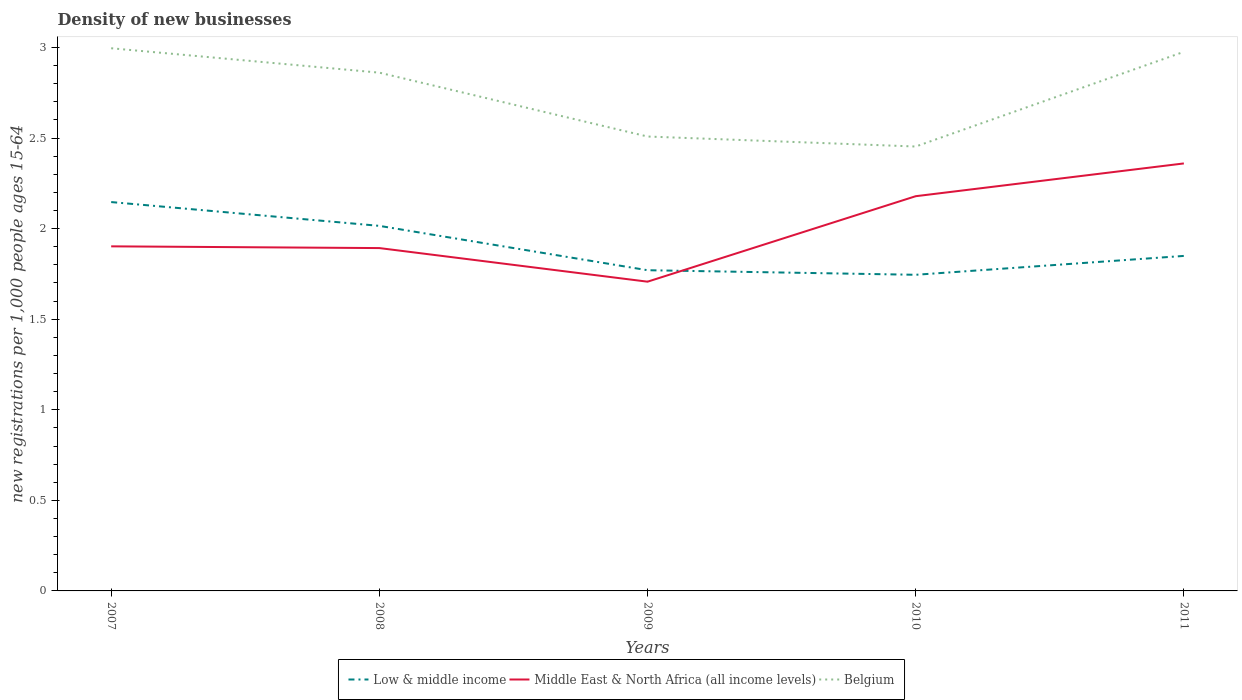How many different coloured lines are there?
Your answer should be compact. 3. Is the number of lines equal to the number of legend labels?
Your answer should be very brief. Yes. Across all years, what is the maximum number of new registrations in Belgium?
Ensure brevity in your answer.  2.45. In which year was the number of new registrations in Low & middle income maximum?
Give a very brief answer. 2010. What is the total number of new registrations in Belgium in the graph?
Your answer should be very brief. 0.13. What is the difference between the highest and the second highest number of new registrations in Middle East & North Africa (all income levels)?
Your answer should be very brief. 0.65. Is the number of new registrations in Middle East & North Africa (all income levels) strictly greater than the number of new registrations in Low & middle income over the years?
Offer a very short reply. No. How many lines are there?
Your answer should be very brief. 3. Does the graph contain any zero values?
Give a very brief answer. No. Where does the legend appear in the graph?
Provide a short and direct response. Bottom center. What is the title of the graph?
Make the answer very short. Density of new businesses. Does "Singapore" appear as one of the legend labels in the graph?
Provide a succinct answer. No. What is the label or title of the Y-axis?
Provide a short and direct response. New registrations per 1,0 people ages 15-64. What is the new registrations per 1,000 people ages 15-64 of Low & middle income in 2007?
Your answer should be very brief. 2.15. What is the new registrations per 1,000 people ages 15-64 of Middle East & North Africa (all income levels) in 2007?
Offer a very short reply. 1.9. What is the new registrations per 1,000 people ages 15-64 in Belgium in 2007?
Ensure brevity in your answer.  3. What is the new registrations per 1,000 people ages 15-64 in Low & middle income in 2008?
Your response must be concise. 2.02. What is the new registrations per 1,000 people ages 15-64 in Middle East & North Africa (all income levels) in 2008?
Keep it short and to the point. 1.89. What is the new registrations per 1,000 people ages 15-64 of Belgium in 2008?
Your answer should be very brief. 2.86. What is the new registrations per 1,000 people ages 15-64 of Low & middle income in 2009?
Provide a short and direct response. 1.77. What is the new registrations per 1,000 people ages 15-64 of Middle East & North Africa (all income levels) in 2009?
Ensure brevity in your answer.  1.71. What is the new registrations per 1,000 people ages 15-64 in Belgium in 2009?
Your answer should be compact. 2.51. What is the new registrations per 1,000 people ages 15-64 of Low & middle income in 2010?
Provide a short and direct response. 1.75. What is the new registrations per 1,000 people ages 15-64 of Middle East & North Africa (all income levels) in 2010?
Make the answer very short. 2.18. What is the new registrations per 1,000 people ages 15-64 of Belgium in 2010?
Keep it short and to the point. 2.45. What is the new registrations per 1,000 people ages 15-64 in Low & middle income in 2011?
Give a very brief answer. 1.85. What is the new registrations per 1,000 people ages 15-64 in Middle East & North Africa (all income levels) in 2011?
Your response must be concise. 2.36. What is the new registrations per 1,000 people ages 15-64 in Belgium in 2011?
Your response must be concise. 2.98. Across all years, what is the maximum new registrations per 1,000 people ages 15-64 in Low & middle income?
Give a very brief answer. 2.15. Across all years, what is the maximum new registrations per 1,000 people ages 15-64 in Middle East & North Africa (all income levels)?
Offer a very short reply. 2.36. Across all years, what is the maximum new registrations per 1,000 people ages 15-64 of Belgium?
Your answer should be compact. 3. Across all years, what is the minimum new registrations per 1,000 people ages 15-64 of Low & middle income?
Provide a succinct answer. 1.75. Across all years, what is the minimum new registrations per 1,000 people ages 15-64 in Middle East & North Africa (all income levels)?
Your answer should be very brief. 1.71. Across all years, what is the minimum new registrations per 1,000 people ages 15-64 in Belgium?
Make the answer very short. 2.45. What is the total new registrations per 1,000 people ages 15-64 in Low & middle income in the graph?
Ensure brevity in your answer.  9.53. What is the total new registrations per 1,000 people ages 15-64 of Middle East & North Africa (all income levels) in the graph?
Provide a succinct answer. 10.04. What is the total new registrations per 1,000 people ages 15-64 in Belgium in the graph?
Offer a very short reply. 13.8. What is the difference between the new registrations per 1,000 people ages 15-64 of Low & middle income in 2007 and that in 2008?
Give a very brief answer. 0.13. What is the difference between the new registrations per 1,000 people ages 15-64 of Middle East & North Africa (all income levels) in 2007 and that in 2008?
Provide a succinct answer. 0.01. What is the difference between the new registrations per 1,000 people ages 15-64 of Belgium in 2007 and that in 2008?
Give a very brief answer. 0.13. What is the difference between the new registrations per 1,000 people ages 15-64 of Low & middle income in 2007 and that in 2009?
Your answer should be very brief. 0.38. What is the difference between the new registrations per 1,000 people ages 15-64 in Middle East & North Africa (all income levels) in 2007 and that in 2009?
Your response must be concise. 0.2. What is the difference between the new registrations per 1,000 people ages 15-64 in Belgium in 2007 and that in 2009?
Offer a terse response. 0.49. What is the difference between the new registrations per 1,000 people ages 15-64 in Low & middle income in 2007 and that in 2010?
Your answer should be compact. 0.4. What is the difference between the new registrations per 1,000 people ages 15-64 of Middle East & North Africa (all income levels) in 2007 and that in 2010?
Your answer should be very brief. -0.28. What is the difference between the new registrations per 1,000 people ages 15-64 of Belgium in 2007 and that in 2010?
Keep it short and to the point. 0.54. What is the difference between the new registrations per 1,000 people ages 15-64 in Low & middle income in 2007 and that in 2011?
Offer a terse response. 0.3. What is the difference between the new registrations per 1,000 people ages 15-64 in Middle East & North Africa (all income levels) in 2007 and that in 2011?
Ensure brevity in your answer.  -0.46. What is the difference between the new registrations per 1,000 people ages 15-64 of Belgium in 2007 and that in 2011?
Ensure brevity in your answer.  0.02. What is the difference between the new registrations per 1,000 people ages 15-64 in Low & middle income in 2008 and that in 2009?
Offer a very short reply. 0.24. What is the difference between the new registrations per 1,000 people ages 15-64 of Middle East & North Africa (all income levels) in 2008 and that in 2009?
Offer a terse response. 0.19. What is the difference between the new registrations per 1,000 people ages 15-64 of Belgium in 2008 and that in 2009?
Your answer should be compact. 0.35. What is the difference between the new registrations per 1,000 people ages 15-64 of Low & middle income in 2008 and that in 2010?
Provide a short and direct response. 0.27. What is the difference between the new registrations per 1,000 people ages 15-64 of Middle East & North Africa (all income levels) in 2008 and that in 2010?
Keep it short and to the point. -0.29. What is the difference between the new registrations per 1,000 people ages 15-64 of Belgium in 2008 and that in 2010?
Offer a terse response. 0.41. What is the difference between the new registrations per 1,000 people ages 15-64 of Low & middle income in 2008 and that in 2011?
Keep it short and to the point. 0.17. What is the difference between the new registrations per 1,000 people ages 15-64 of Middle East & North Africa (all income levels) in 2008 and that in 2011?
Ensure brevity in your answer.  -0.47. What is the difference between the new registrations per 1,000 people ages 15-64 of Belgium in 2008 and that in 2011?
Your answer should be compact. -0.12. What is the difference between the new registrations per 1,000 people ages 15-64 of Low & middle income in 2009 and that in 2010?
Your response must be concise. 0.03. What is the difference between the new registrations per 1,000 people ages 15-64 in Middle East & North Africa (all income levels) in 2009 and that in 2010?
Your response must be concise. -0.47. What is the difference between the new registrations per 1,000 people ages 15-64 of Belgium in 2009 and that in 2010?
Offer a very short reply. 0.06. What is the difference between the new registrations per 1,000 people ages 15-64 of Low & middle income in 2009 and that in 2011?
Provide a succinct answer. -0.08. What is the difference between the new registrations per 1,000 people ages 15-64 of Middle East & North Africa (all income levels) in 2009 and that in 2011?
Your response must be concise. -0.65. What is the difference between the new registrations per 1,000 people ages 15-64 of Belgium in 2009 and that in 2011?
Ensure brevity in your answer.  -0.47. What is the difference between the new registrations per 1,000 people ages 15-64 of Low & middle income in 2010 and that in 2011?
Offer a very short reply. -0.1. What is the difference between the new registrations per 1,000 people ages 15-64 of Middle East & North Africa (all income levels) in 2010 and that in 2011?
Offer a very short reply. -0.18. What is the difference between the new registrations per 1,000 people ages 15-64 in Belgium in 2010 and that in 2011?
Give a very brief answer. -0.52. What is the difference between the new registrations per 1,000 people ages 15-64 in Low & middle income in 2007 and the new registrations per 1,000 people ages 15-64 in Middle East & North Africa (all income levels) in 2008?
Provide a succinct answer. 0.25. What is the difference between the new registrations per 1,000 people ages 15-64 in Low & middle income in 2007 and the new registrations per 1,000 people ages 15-64 in Belgium in 2008?
Your response must be concise. -0.71. What is the difference between the new registrations per 1,000 people ages 15-64 of Middle East & North Africa (all income levels) in 2007 and the new registrations per 1,000 people ages 15-64 of Belgium in 2008?
Your answer should be very brief. -0.96. What is the difference between the new registrations per 1,000 people ages 15-64 in Low & middle income in 2007 and the new registrations per 1,000 people ages 15-64 in Middle East & North Africa (all income levels) in 2009?
Your answer should be very brief. 0.44. What is the difference between the new registrations per 1,000 people ages 15-64 in Low & middle income in 2007 and the new registrations per 1,000 people ages 15-64 in Belgium in 2009?
Your response must be concise. -0.36. What is the difference between the new registrations per 1,000 people ages 15-64 of Middle East & North Africa (all income levels) in 2007 and the new registrations per 1,000 people ages 15-64 of Belgium in 2009?
Make the answer very short. -0.61. What is the difference between the new registrations per 1,000 people ages 15-64 of Low & middle income in 2007 and the new registrations per 1,000 people ages 15-64 of Middle East & North Africa (all income levels) in 2010?
Your answer should be compact. -0.03. What is the difference between the new registrations per 1,000 people ages 15-64 of Low & middle income in 2007 and the new registrations per 1,000 people ages 15-64 of Belgium in 2010?
Keep it short and to the point. -0.31. What is the difference between the new registrations per 1,000 people ages 15-64 in Middle East & North Africa (all income levels) in 2007 and the new registrations per 1,000 people ages 15-64 in Belgium in 2010?
Your answer should be compact. -0.55. What is the difference between the new registrations per 1,000 people ages 15-64 of Low & middle income in 2007 and the new registrations per 1,000 people ages 15-64 of Middle East & North Africa (all income levels) in 2011?
Provide a short and direct response. -0.21. What is the difference between the new registrations per 1,000 people ages 15-64 of Low & middle income in 2007 and the new registrations per 1,000 people ages 15-64 of Belgium in 2011?
Ensure brevity in your answer.  -0.83. What is the difference between the new registrations per 1,000 people ages 15-64 of Middle East & North Africa (all income levels) in 2007 and the new registrations per 1,000 people ages 15-64 of Belgium in 2011?
Your answer should be very brief. -1.07. What is the difference between the new registrations per 1,000 people ages 15-64 of Low & middle income in 2008 and the new registrations per 1,000 people ages 15-64 of Middle East & North Africa (all income levels) in 2009?
Your answer should be very brief. 0.31. What is the difference between the new registrations per 1,000 people ages 15-64 in Low & middle income in 2008 and the new registrations per 1,000 people ages 15-64 in Belgium in 2009?
Offer a terse response. -0.49. What is the difference between the new registrations per 1,000 people ages 15-64 in Middle East & North Africa (all income levels) in 2008 and the new registrations per 1,000 people ages 15-64 in Belgium in 2009?
Your answer should be compact. -0.62. What is the difference between the new registrations per 1,000 people ages 15-64 in Low & middle income in 2008 and the new registrations per 1,000 people ages 15-64 in Middle East & North Africa (all income levels) in 2010?
Ensure brevity in your answer.  -0.16. What is the difference between the new registrations per 1,000 people ages 15-64 of Low & middle income in 2008 and the new registrations per 1,000 people ages 15-64 of Belgium in 2010?
Ensure brevity in your answer.  -0.44. What is the difference between the new registrations per 1,000 people ages 15-64 in Middle East & North Africa (all income levels) in 2008 and the new registrations per 1,000 people ages 15-64 in Belgium in 2010?
Provide a succinct answer. -0.56. What is the difference between the new registrations per 1,000 people ages 15-64 in Low & middle income in 2008 and the new registrations per 1,000 people ages 15-64 in Middle East & North Africa (all income levels) in 2011?
Offer a very short reply. -0.34. What is the difference between the new registrations per 1,000 people ages 15-64 in Low & middle income in 2008 and the new registrations per 1,000 people ages 15-64 in Belgium in 2011?
Offer a terse response. -0.96. What is the difference between the new registrations per 1,000 people ages 15-64 of Middle East & North Africa (all income levels) in 2008 and the new registrations per 1,000 people ages 15-64 of Belgium in 2011?
Offer a very short reply. -1.08. What is the difference between the new registrations per 1,000 people ages 15-64 in Low & middle income in 2009 and the new registrations per 1,000 people ages 15-64 in Middle East & North Africa (all income levels) in 2010?
Ensure brevity in your answer.  -0.41. What is the difference between the new registrations per 1,000 people ages 15-64 in Low & middle income in 2009 and the new registrations per 1,000 people ages 15-64 in Belgium in 2010?
Offer a terse response. -0.68. What is the difference between the new registrations per 1,000 people ages 15-64 in Middle East & North Africa (all income levels) in 2009 and the new registrations per 1,000 people ages 15-64 in Belgium in 2010?
Your answer should be very brief. -0.75. What is the difference between the new registrations per 1,000 people ages 15-64 in Low & middle income in 2009 and the new registrations per 1,000 people ages 15-64 in Middle East & North Africa (all income levels) in 2011?
Your response must be concise. -0.59. What is the difference between the new registrations per 1,000 people ages 15-64 of Low & middle income in 2009 and the new registrations per 1,000 people ages 15-64 of Belgium in 2011?
Your answer should be very brief. -1.21. What is the difference between the new registrations per 1,000 people ages 15-64 of Middle East & North Africa (all income levels) in 2009 and the new registrations per 1,000 people ages 15-64 of Belgium in 2011?
Provide a short and direct response. -1.27. What is the difference between the new registrations per 1,000 people ages 15-64 of Low & middle income in 2010 and the new registrations per 1,000 people ages 15-64 of Middle East & North Africa (all income levels) in 2011?
Give a very brief answer. -0.61. What is the difference between the new registrations per 1,000 people ages 15-64 of Low & middle income in 2010 and the new registrations per 1,000 people ages 15-64 of Belgium in 2011?
Ensure brevity in your answer.  -1.23. What is the difference between the new registrations per 1,000 people ages 15-64 in Middle East & North Africa (all income levels) in 2010 and the new registrations per 1,000 people ages 15-64 in Belgium in 2011?
Ensure brevity in your answer.  -0.8. What is the average new registrations per 1,000 people ages 15-64 of Low & middle income per year?
Make the answer very short. 1.91. What is the average new registrations per 1,000 people ages 15-64 of Middle East & North Africa (all income levels) per year?
Keep it short and to the point. 2.01. What is the average new registrations per 1,000 people ages 15-64 of Belgium per year?
Your answer should be very brief. 2.76. In the year 2007, what is the difference between the new registrations per 1,000 people ages 15-64 of Low & middle income and new registrations per 1,000 people ages 15-64 of Middle East & North Africa (all income levels)?
Offer a very short reply. 0.24. In the year 2007, what is the difference between the new registrations per 1,000 people ages 15-64 of Low & middle income and new registrations per 1,000 people ages 15-64 of Belgium?
Provide a short and direct response. -0.85. In the year 2007, what is the difference between the new registrations per 1,000 people ages 15-64 of Middle East & North Africa (all income levels) and new registrations per 1,000 people ages 15-64 of Belgium?
Provide a short and direct response. -1.09. In the year 2008, what is the difference between the new registrations per 1,000 people ages 15-64 in Low & middle income and new registrations per 1,000 people ages 15-64 in Middle East & North Africa (all income levels)?
Offer a terse response. 0.12. In the year 2008, what is the difference between the new registrations per 1,000 people ages 15-64 in Low & middle income and new registrations per 1,000 people ages 15-64 in Belgium?
Make the answer very short. -0.85. In the year 2008, what is the difference between the new registrations per 1,000 people ages 15-64 of Middle East & North Africa (all income levels) and new registrations per 1,000 people ages 15-64 of Belgium?
Provide a short and direct response. -0.97. In the year 2009, what is the difference between the new registrations per 1,000 people ages 15-64 in Low & middle income and new registrations per 1,000 people ages 15-64 in Middle East & North Africa (all income levels)?
Offer a terse response. 0.06. In the year 2009, what is the difference between the new registrations per 1,000 people ages 15-64 in Low & middle income and new registrations per 1,000 people ages 15-64 in Belgium?
Make the answer very short. -0.74. In the year 2009, what is the difference between the new registrations per 1,000 people ages 15-64 of Middle East & North Africa (all income levels) and new registrations per 1,000 people ages 15-64 of Belgium?
Your answer should be compact. -0.8. In the year 2010, what is the difference between the new registrations per 1,000 people ages 15-64 in Low & middle income and new registrations per 1,000 people ages 15-64 in Middle East & North Africa (all income levels)?
Your answer should be compact. -0.43. In the year 2010, what is the difference between the new registrations per 1,000 people ages 15-64 in Low & middle income and new registrations per 1,000 people ages 15-64 in Belgium?
Your answer should be very brief. -0.71. In the year 2010, what is the difference between the new registrations per 1,000 people ages 15-64 in Middle East & North Africa (all income levels) and new registrations per 1,000 people ages 15-64 in Belgium?
Your answer should be compact. -0.27. In the year 2011, what is the difference between the new registrations per 1,000 people ages 15-64 in Low & middle income and new registrations per 1,000 people ages 15-64 in Middle East & North Africa (all income levels)?
Offer a very short reply. -0.51. In the year 2011, what is the difference between the new registrations per 1,000 people ages 15-64 of Low & middle income and new registrations per 1,000 people ages 15-64 of Belgium?
Offer a very short reply. -1.13. In the year 2011, what is the difference between the new registrations per 1,000 people ages 15-64 in Middle East & North Africa (all income levels) and new registrations per 1,000 people ages 15-64 in Belgium?
Your answer should be very brief. -0.62. What is the ratio of the new registrations per 1,000 people ages 15-64 of Low & middle income in 2007 to that in 2008?
Ensure brevity in your answer.  1.07. What is the ratio of the new registrations per 1,000 people ages 15-64 in Belgium in 2007 to that in 2008?
Offer a terse response. 1.05. What is the ratio of the new registrations per 1,000 people ages 15-64 in Low & middle income in 2007 to that in 2009?
Offer a very short reply. 1.21. What is the ratio of the new registrations per 1,000 people ages 15-64 of Middle East & North Africa (all income levels) in 2007 to that in 2009?
Give a very brief answer. 1.11. What is the ratio of the new registrations per 1,000 people ages 15-64 of Belgium in 2007 to that in 2009?
Your response must be concise. 1.19. What is the ratio of the new registrations per 1,000 people ages 15-64 in Low & middle income in 2007 to that in 2010?
Your answer should be very brief. 1.23. What is the ratio of the new registrations per 1,000 people ages 15-64 in Middle East & North Africa (all income levels) in 2007 to that in 2010?
Make the answer very short. 0.87. What is the ratio of the new registrations per 1,000 people ages 15-64 in Belgium in 2007 to that in 2010?
Make the answer very short. 1.22. What is the ratio of the new registrations per 1,000 people ages 15-64 in Low & middle income in 2007 to that in 2011?
Offer a very short reply. 1.16. What is the ratio of the new registrations per 1,000 people ages 15-64 of Middle East & North Africa (all income levels) in 2007 to that in 2011?
Offer a terse response. 0.81. What is the ratio of the new registrations per 1,000 people ages 15-64 of Low & middle income in 2008 to that in 2009?
Keep it short and to the point. 1.14. What is the ratio of the new registrations per 1,000 people ages 15-64 in Middle East & North Africa (all income levels) in 2008 to that in 2009?
Give a very brief answer. 1.11. What is the ratio of the new registrations per 1,000 people ages 15-64 of Belgium in 2008 to that in 2009?
Keep it short and to the point. 1.14. What is the ratio of the new registrations per 1,000 people ages 15-64 in Low & middle income in 2008 to that in 2010?
Offer a terse response. 1.15. What is the ratio of the new registrations per 1,000 people ages 15-64 of Middle East & North Africa (all income levels) in 2008 to that in 2010?
Your answer should be very brief. 0.87. What is the ratio of the new registrations per 1,000 people ages 15-64 in Belgium in 2008 to that in 2010?
Provide a succinct answer. 1.17. What is the ratio of the new registrations per 1,000 people ages 15-64 of Low & middle income in 2008 to that in 2011?
Your answer should be very brief. 1.09. What is the ratio of the new registrations per 1,000 people ages 15-64 of Middle East & North Africa (all income levels) in 2008 to that in 2011?
Your answer should be compact. 0.8. What is the ratio of the new registrations per 1,000 people ages 15-64 of Belgium in 2008 to that in 2011?
Your answer should be compact. 0.96. What is the ratio of the new registrations per 1,000 people ages 15-64 in Low & middle income in 2009 to that in 2010?
Offer a terse response. 1.01. What is the ratio of the new registrations per 1,000 people ages 15-64 of Middle East & North Africa (all income levels) in 2009 to that in 2010?
Your answer should be compact. 0.78. What is the ratio of the new registrations per 1,000 people ages 15-64 of Belgium in 2009 to that in 2010?
Make the answer very short. 1.02. What is the ratio of the new registrations per 1,000 people ages 15-64 of Low & middle income in 2009 to that in 2011?
Offer a very short reply. 0.96. What is the ratio of the new registrations per 1,000 people ages 15-64 in Middle East & North Africa (all income levels) in 2009 to that in 2011?
Offer a very short reply. 0.72. What is the ratio of the new registrations per 1,000 people ages 15-64 in Belgium in 2009 to that in 2011?
Offer a very short reply. 0.84. What is the ratio of the new registrations per 1,000 people ages 15-64 of Low & middle income in 2010 to that in 2011?
Keep it short and to the point. 0.94. What is the ratio of the new registrations per 1,000 people ages 15-64 of Middle East & North Africa (all income levels) in 2010 to that in 2011?
Keep it short and to the point. 0.92. What is the ratio of the new registrations per 1,000 people ages 15-64 in Belgium in 2010 to that in 2011?
Keep it short and to the point. 0.82. What is the difference between the highest and the second highest new registrations per 1,000 people ages 15-64 in Low & middle income?
Ensure brevity in your answer.  0.13. What is the difference between the highest and the second highest new registrations per 1,000 people ages 15-64 in Middle East & North Africa (all income levels)?
Offer a very short reply. 0.18. What is the difference between the highest and the second highest new registrations per 1,000 people ages 15-64 in Belgium?
Keep it short and to the point. 0.02. What is the difference between the highest and the lowest new registrations per 1,000 people ages 15-64 in Low & middle income?
Give a very brief answer. 0.4. What is the difference between the highest and the lowest new registrations per 1,000 people ages 15-64 of Middle East & North Africa (all income levels)?
Your answer should be compact. 0.65. What is the difference between the highest and the lowest new registrations per 1,000 people ages 15-64 of Belgium?
Offer a very short reply. 0.54. 